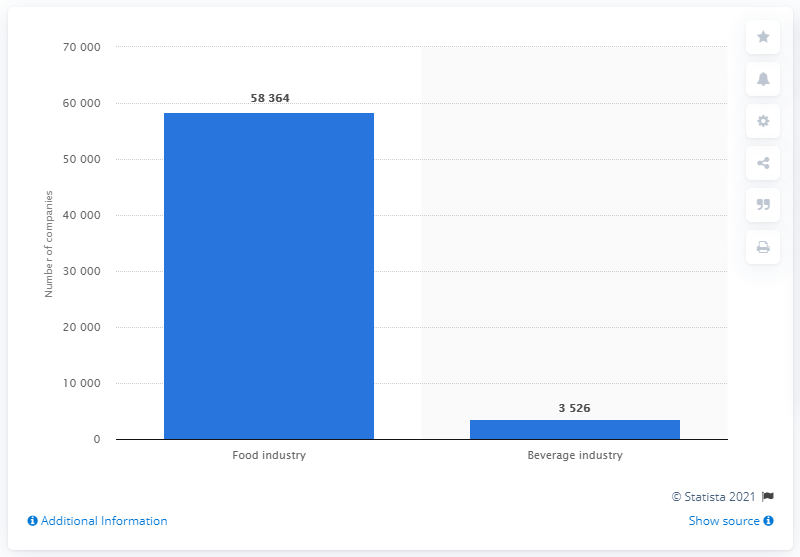How many companies were in the food and beverage industry in Italy in the second quarter of 2017? In the second quarter of 2017, there were 58,364 companies in the food industry in Italy. This number reflects a significant sector within the Italian economy, showcasing its role as a major player in food production and distribution throughout Europe. 